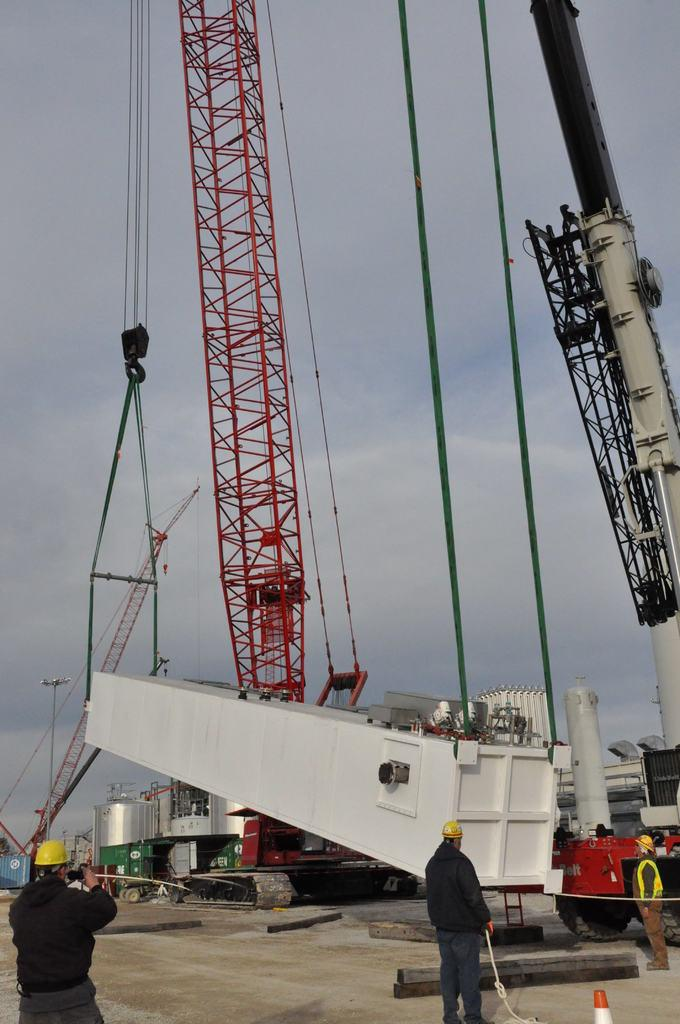What type of machinery is present in the image? There is a crane in the image. What are the ropes used for in the image? The ropes are likely used for lifting or securing objects in conjunction with the crane. What other large object can be seen in the image? There is a tank in the image. How many people are present in the image? Three persons are standing at the bottom of the image. What are the persons wearing on their heads? The persons are wearing yellow helmets. What is visible in the background of the image? The sky is visible in the background of the image. What type of room is visible in the image? There is no room visible in the image; it features a crane, ropes, a tank, and people wearing yellow helmets. What is the name of the company that owns the crane in the image? The provided facts do not mention the name of the company that owns the crane, so it cannot be determined from the image. 